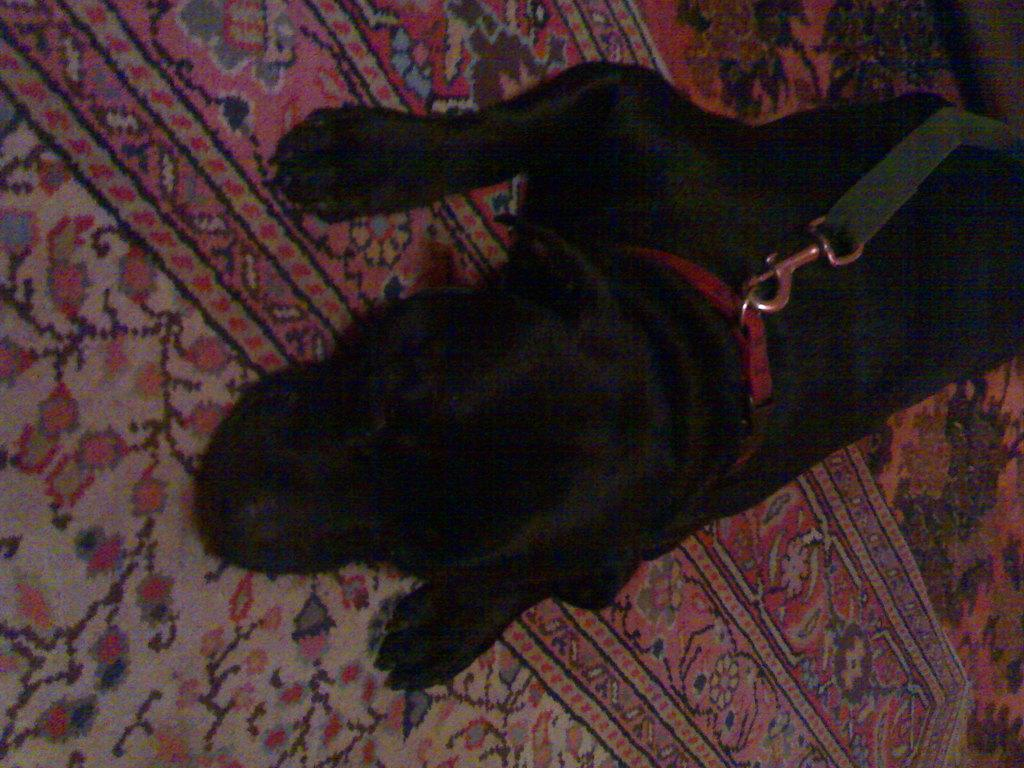What animal can be seen in the image? There is a dog in the image. What surface is the dog lying on? The dog is lying on a carpet. Are there any accessories on the dog? Yes, there is a belt and a leash on the dog. What type of lipstick is the dog wearing in the image? There is no lipstick or any indication of makeup on the dog in the image. 